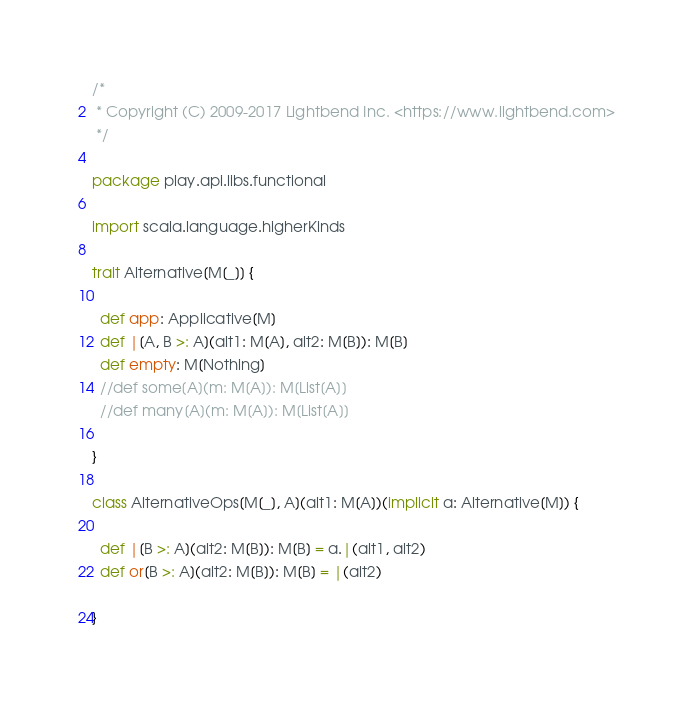<code> <loc_0><loc_0><loc_500><loc_500><_Scala_>/*
 * Copyright (C) 2009-2017 Lightbend Inc. <https://www.lightbend.com>
 */

package play.api.libs.functional

import scala.language.higherKinds

trait Alternative[M[_]] {

  def app: Applicative[M]
  def |[A, B >: A](alt1: M[A], alt2: M[B]): M[B]
  def empty: M[Nothing]
  //def some[A](m: M[A]): M[List[A]]
  //def many[A](m: M[A]): M[List[A]]

}

class AlternativeOps[M[_], A](alt1: M[A])(implicit a: Alternative[M]) {

  def |[B >: A](alt2: M[B]): M[B] = a.|(alt1, alt2)
  def or[B >: A](alt2: M[B]): M[B] = |(alt2)

}

</code> 